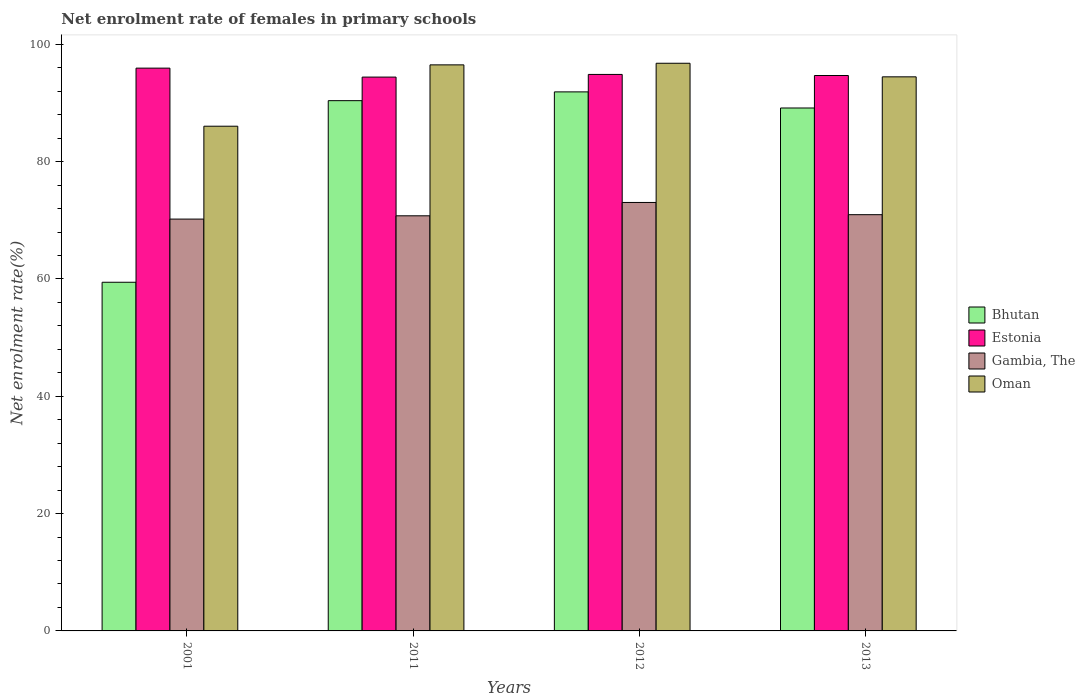How many different coloured bars are there?
Your response must be concise. 4. Are the number of bars per tick equal to the number of legend labels?
Your response must be concise. Yes. Are the number of bars on each tick of the X-axis equal?
Provide a short and direct response. Yes. In how many cases, is the number of bars for a given year not equal to the number of legend labels?
Provide a succinct answer. 0. What is the net enrolment rate of females in primary schools in Bhutan in 2011?
Offer a terse response. 90.39. Across all years, what is the maximum net enrolment rate of females in primary schools in Bhutan?
Your answer should be very brief. 91.89. Across all years, what is the minimum net enrolment rate of females in primary schools in Oman?
Provide a short and direct response. 86.04. What is the total net enrolment rate of females in primary schools in Bhutan in the graph?
Your answer should be very brief. 330.86. What is the difference between the net enrolment rate of females in primary schools in Bhutan in 2011 and that in 2012?
Give a very brief answer. -1.5. What is the difference between the net enrolment rate of females in primary schools in Estonia in 2001 and the net enrolment rate of females in primary schools in Gambia, The in 2012?
Ensure brevity in your answer.  22.9. What is the average net enrolment rate of females in primary schools in Estonia per year?
Ensure brevity in your answer.  94.97. In the year 2012, what is the difference between the net enrolment rate of females in primary schools in Oman and net enrolment rate of females in primary schools in Bhutan?
Offer a very short reply. 4.88. In how many years, is the net enrolment rate of females in primary schools in Oman greater than 52 %?
Keep it short and to the point. 4. What is the ratio of the net enrolment rate of females in primary schools in Oman in 2001 to that in 2013?
Offer a terse response. 0.91. Is the difference between the net enrolment rate of females in primary schools in Oman in 2001 and 2011 greater than the difference between the net enrolment rate of females in primary schools in Bhutan in 2001 and 2011?
Make the answer very short. Yes. What is the difference between the highest and the second highest net enrolment rate of females in primary schools in Bhutan?
Give a very brief answer. 1.5. What is the difference between the highest and the lowest net enrolment rate of females in primary schools in Gambia, The?
Provide a short and direct response. 2.83. In how many years, is the net enrolment rate of females in primary schools in Oman greater than the average net enrolment rate of females in primary schools in Oman taken over all years?
Keep it short and to the point. 3. Is the sum of the net enrolment rate of females in primary schools in Estonia in 2011 and 2012 greater than the maximum net enrolment rate of females in primary schools in Gambia, The across all years?
Provide a succinct answer. Yes. What does the 3rd bar from the left in 2011 represents?
Your answer should be compact. Gambia, The. What does the 1st bar from the right in 2012 represents?
Ensure brevity in your answer.  Oman. Is it the case that in every year, the sum of the net enrolment rate of females in primary schools in Gambia, The and net enrolment rate of females in primary schools in Estonia is greater than the net enrolment rate of females in primary schools in Oman?
Your answer should be very brief. Yes. Are all the bars in the graph horizontal?
Make the answer very short. No. Where does the legend appear in the graph?
Give a very brief answer. Center right. How many legend labels are there?
Make the answer very short. 4. How are the legend labels stacked?
Provide a succinct answer. Vertical. What is the title of the graph?
Make the answer very short. Net enrolment rate of females in primary schools. What is the label or title of the Y-axis?
Provide a short and direct response. Net enrolment rate(%). What is the Net enrolment rate(%) in Bhutan in 2001?
Give a very brief answer. 59.44. What is the Net enrolment rate(%) of Estonia in 2001?
Provide a short and direct response. 95.94. What is the Net enrolment rate(%) of Gambia, The in 2001?
Offer a very short reply. 70.2. What is the Net enrolment rate(%) in Oman in 2001?
Offer a very short reply. 86.04. What is the Net enrolment rate(%) of Bhutan in 2011?
Your answer should be compact. 90.39. What is the Net enrolment rate(%) in Estonia in 2011?
Offer a terse response. 94.41. What is the Net enrolment rate(%) in Gambia, The in 2011?
Ensure brevity in your answer.  70.76. What is the Net enrolment rate(%) in Oman in 2011?
Keep it short and to the point. 96.49. What is the Net enrolment rate(%) of Bhutan in 2012?
Your response must be concise. 91.89. What is the Net enrolment rate(%) in Estonia in 2012?
Give a very brief answer. 94.86. What is the Net enrolment rate(%) of Gambia, The in 2012?
Give a very brief answer. 73.04. What is the Net enrolment rate(%) of Oman in 2012?
Offer a very short reply. 96.77. What is the Net enrolment rate(%) of Bhutan in 2013?
Ensure brevity in your answer.  89.14. What is the Net enrolment rate(%) in Estonia in 2013?
Make the answer very short. 94.68. What is the Net enrolment rate(%) of Gambia, The in 2013?
Offer a terse response. 70.96. What is the Net enrolment rate(%) of Oman in 2013?
Your answer should be very brief. 94.45. Across all years, what is the maximum Net enrolment rate(%) in Bhutan?
Offer a terse response. 91.89. Across all years, what is the maximum Net enrolment rate(%) of Estonia?
Offer a very short reply. 95.94. Across all years, what is the maximum Net enrolment rate(%) of Gambia, The?
Your response must be concise. 73.04. Across all years, what is the maximum Net enrolment rate(%) in Oman?
Give a very brief answer. 96.77. Across all years, what is the minimum Net enrolment rate(%) of Bhutan?
Your answer should be compact. 59.44. Across all years, what is the minimum Net enrolment rate(%) of Estonia?
Offer a terse response. 94.41. Across all years, what is the minimum Net enrolment rate(%) of Gambia, The?
Provide a succinct answer. 70.2. Across all years, what is the minimum Net enrolment rate(%) in Oman?
Offer a terse response. 86.04. What is the total Net enrolment rate(%) in Bhutan in the graph?
Keep it short and to the point. 330.86. What is the total Net enrolment rate(%) of Estonia in the graph?
Keep it short and to the point. 379.89. What is the total Net enrolment rate(%) in Gambia, The in the graph?
Keep it short and to the point. 284.97. What is the total Net enrolment rate(%) in Oman in the graph?
Offer a terse response. 373.75. What is the difference between the Net enrolment rate(%) in Bhutan in 2001 and that in 2011?
Keep it short and to the point. -30.96. What is the difference between the Net enrolment rate(%) of Estonia in 2001 and that in 2011?
Your answer should be very brief. 1.53. What is the difference between the Net enrolment rate(%) of Gambia, The in 2001 and that in 2011?
Ensure brevity in your answer.  -0.56. What is the difference between the Net enrolment rate(%) in Oman in 2001 and that in 2011?
Provide a short and direct response. -10.46. What is the difference between the Net enrolment rate(%) in Bhutan in 2001 and that in 2012?
Provide a succinct answer. -32.45. What is the difference between the Net enrolment rate(%) of Estonia in 2001 and that in 2012?
Make the answer very short. 1.07. What is the difference between the Net enrolment rate(%) in Gambia, The in 2001 and that in 2012?
Give a very brief answer. -2.83. What is the difference between the Net enrolment rate(%) in Oman in 2001 and that in 2012?
Offer a very short reply. -10.73. What is the difference between the Net enrolment rate(%) in Bhutan in 2001 and that in 2013?
Keep it short and to the point. -29.71. What is the difference between the Net enrolment rate(%) in Estonia in 2001 and that in 2013?
Your answer should be very brief. 1.26. What is the difference between the Net enrolment rate(%) in Gambia, The in 2001 and that in 2013?
Provide a succinct answer. -0.75. What is the difference between the Net enrolment rate(%) of Oman in 2001 and that in 2013?
Make the answer very short. -8.42. What is the difference between the Net enrolment rate(%) in Bhutan in 2011 and that in 2012?
Offer a very short reply. -1.5. What is the difference between the Net enrolment rate(%) in Estonia in 2011 and that in 2012?
Your answer should be very brief. -0.45. What is the difference between the Net enrolment rate(%) in Gambia, The in 2011 and that in 2012?
Give a very brief answer. -2.28. What is the difference between the Net enrolment rate(%) of Oman in 2011 and that in 2012?
Make the answer very short. -0.28. What is the difference between the Net enrolment rate(%) of Bhutan in 2011 and that in 2013?
Give a very brief answer. 1.25. What is the difference between the Net enrolment rate(%) in Estonia in 2011 and that in 2013?
Ensure brevity in your answer.  -0.27. What is the difference between the Net enrolment rate(%) in Gambia, The in 2011 and that in 2013?
Your answer should be compact. -0.19. What is the difference between the Net enrolment rate(%) in Oman in 2011 and that in 2013?
Keep it short and to the point. 2.04. What is the difference between the Net enrolment rate(%) in Bhutan in 2012 and that in 2013?
Your response must be concise. 2.75. What is the difference between the Net enrolment rate(%) of Estonia in 2012 and that in 2013?
Offer a very short reply. 0.18. What is the difference between the Net enrolment rate(%) of Gambia, The in 2012 and that in 2013?
Provide a short and direct response. 2.08. What is the difference between the Net enrolment rate(%) of Oman in 2012 and that in 2013?
Your answer should be very brief. 2.31. What is the difference between the Net enrolment rate(%) in Bhutan in 2001 and the Net enrolment rate(%) in Estonia in 2011?
Provide a short and direct response. -34.97. What is the difference between the Net enrolment rate(%) of Bhutan in 2001 and the Net enrolment rate(%) of Gambia, The in 2011?
Provide a succinct answer. -11.33. What is the difference between the Net enrolment rate(%) in Bhutan in 2001 and the Net enrolment rate(%) in Oman in 2011?
Keep it short and to the point. -37.06. What is the difference between the Net enrolment rate(%) in Estonia in 2001 and the Net enrolment rate(%) in Gambia, The in 2011?
Your answer should be very brief. 25.17. What is the difference between the Net enrolment rate(%) of Estonia in 2001 and the Net enrolment rate(%) of Oman in 2011?
Make the answer very short. -0.56. What is the difference between the Net enrolment rate(%) in Gambia, The in 2001 and the Net enrolment rate(%) in Oman in 2011?
Your answer should be very brief. -26.29. What is the difference between the Net enrolment rate(%) of Bhutan in 2001 and the Net enrolment rate(%) of Estonia in 2012?
Offer a terse response. -35.43. What is the difference between the Net enrolment rate(%) in Bhutan in 2001 and the Net enrolment rate(%) in Gambia, The in 2012?
Offer a terse response. -13.6. What is the difference between the Net enrolment rate(%) of Bhutan in 2001 and the Net enrolment rate(%) of Oman in 2012?
Offer a very short reply. -37.33. What is the difference between the Net enrolment rate(%) of Estonia in 2001 and the Net enrolment rate(%) of Gambia, The in 2012?
Give a very brief answer. 22.9. What is the difference between the Net enrolment rate(%) in Estonia in 2001 and the Net enrolment rate(%) in Oman in 2012?
Offer a very short reply. -0.83. What is the difference between the Net enrolment rate(%) of Gambia, The in 2001 and the Net enrolment rate(%) of Oman in 2012?
Provide a short and direct response. -26.56. What is the difference between the Net enrolment rate(%) of Bhutan in 2001 and the Net enrolment rate(%) of Estonia in 2013?
Offer a terse response. -35.24. What is the difference between the Net enrolment rate(%) in Bhutan in 2001 and the Net enrolment rate(%) in Gambia, The in 2013?
Your answer should be compact. -11.52. What is the difference between the Net enrolment rate(%) of Bhutan in 2001 and the Net enrolment rate(%) of Oman in 2013?
Make the answer very short. -35.02. What is the difference between the Net enrolment rate(%) of Estonia in 2001 and the Net enrolment rate(%) of Gambia, The in 2013?
Offer a terse response. 24.98. What is the difference between the Net enrolment rate(%) in Estonia in 2001 and the Net enrolment rate(%) in Oman in 2013?
Provide a short and direct response. 1.48. What is the difference between the Net enrolment rate(%) in Gambia, The in 2001 and the Net enrolment rate(%) in Oman in 2013?
Ensure brevity in your answer.  -24.25. What is the difference between the Net enrolment rate(%) of Bhutan in 2011 and the Net enrolment rate(%) of Estonia in 2012?
Your response must be concise. -4.47. What is the difference between the Net enrolment rate(%) in Bhutan in 2011 and the Net enrolment rate(%) in Gambia, The in 2012?
Give a very brief answer. 17.35. What is the difference between the Net enrolment rate(%) in Bhutan in 2011 and the Net enrolment rate(%) in Oman in 2012?
Your response must be concise. -6.38. What is the difference between the Net enrolment rate(%) of Estonia in 2011 and the Net enrolment rate(%) of Gambia, The in 2012?
Your answer should be compact. 21.37. What is the difference between the Net enrolment rate(%) of Estonia in 2011 and the Net enrolment rate(%) of Oman in 2012?
Your answer should be very brief. -2.36. What is the difference between the Net enrolment rate(%) of Gambia, The in 2011 and the Net enrolment rate(%) of Oman in 2012?
Offer a terse response. -26. What is the difference between the Net enrolment rate(%) of Bhutan in 2011 and the Net enrolment rate(%) of Estonia in 2013?
Offer a very short reply. -4.29. What is the difference between the Net enrolment rate(%) of Bhutan in 2011 and the Net enrolment rate(%) of Gambia, The in 2013?
Keep it short and to the point. 19.43. What is the difference between the Net enrolment rate(%) of Bhutan in 2011 and the Net enrolment rate(%) of Oman in 2013?
Offer a very short reply. -4.06. What is the difference between the Net enrolment rate(%) in Estonia in 2011 and the Net enrolment rate(%) in Gambia, The in 2013?
Offer a terse response. 23.45. What is the difference between the Net enrolment rate(%) of Estonia in 2011 and the Net enrolment rate(%) of Oman in 2013?
Make the answer very short. -0.04. What is the difference between the Net enrolment rate(%) of Gambia, The in 2011 and the Net enrolment rate(%) of Oman in 2013?
Offer a very short reply. -23.69. What is the difference between the Net enrolment rate(%) in Bhutan in 2012 and the Net enrolment rate(%) in Estonia in 2013?
Give a very brief answer. -2.79. What is the difference between the Net enrolment rate(%) in Bhutan in 2012 and the Net enrolment rate(%) in Gambia, The in 2013?
Ensure brevity in your answer.  20.93. What is the difference between the Net enrolment rate(%) of Bhutan in 2012 and the Net enrolment rate(%) of Oman in 2013?
Offer a very short reply. -2.56. What is the difference between the Net enrolment rate(%) of Estonia in 2012 and the Net enrolment rate(%) of Gambia, The in 2013?
Provide a short and direct response. 23.91. What is the difference between the Net enrolment rate(%) in Estonia in 2012 and the Net enrolment rate(%) in Oman in 2013?
Keep it short and to the point. 0.41. What is the difference between the Net enrolment rate(%) in Gambia, The in 2012 and the Net enrolment rate(%) in Oman in 2013?
Offer a very short reply. -21.41. What is the average Net enrolment rate(%) of Bhutan per year?
Provide a succinct answer. 82.72. What is the average Net enrolment rate(%) in Estonia per year?
Provide a succinct answer. 94.97. What is the average Net enrolment rate(%) in Gambia, The per year?
Make the answer very short. 71.24. What is the average Net enrolment rate(%) of Oman per year?
Provide a short and direct response. 93.44. In the year 2001, what is the difference between the Net enrolment rate(%) of Bhutan and Net enrolment rate(%) of Estonia?
Give a very brief answer. -36.5. In the year 2001, what is the difference between the Net enrolment rate(%) of Bhutan and Net enrolment rate(%) of Gambia, The?
Make the answer very short. -10.77. In the year 2001, what is the difference between the Net enrolment rate(%) of Bhutan and Net enrolment rate(%) of Oman?
Your answer should be very brief. -26.6. In the year 2001, what is the difference between the Net enrolment rate(%) in Estonia and Net enrolment rate(%) in Gambia, The?
Provide a short and direct response. 25.73. In the year 2001, what is the difference between the Net enrolment rate(%) of Estonia and Net enrolment rate(%) of Oman?
Make the answer very short. 9.9. In the year 2001, what is the difference between the Net enrolment rate(%) in Gambia, The and Net enrolment rate(%) in Oman?
Provide a short and direct response. -15.83. In the year 2011, what is the difference between the Net enrolment rate(%) of Bhutan and Net enrolment rate(%) of Estonia?
Provide a short and direct response. -4.02. In the year 2011, what is the difference between the Net enrolment rate(%) of Bhutan and Net enrolment rate(%) of Gambia, The?
Offer a very short reply. 19.63. In the year 2011, what is the difference between the Net enrolment rate(%) of Bhutan and Net enrolment rate(%) of Oman?
Give a very brief answer. -6.1. In the year 2011, what is the difference between the Net enrolment rate(%) of Estonia and Net enrolment rate(%) of Gambia, The?
Provide a short and direct response. 23.65. In the year 2011, what is the difference between the Net enrolment rate(%) in Estonia and Net enrolment rate(%) in Oman?
Make the answer very short. -2.08. In the year 2011, what is the difference between the Net enrolment rate(%) in Gambia, The and Net enrolment rate(%) in Oman?
Offer a very short reply. -25.73. In the year 2012, what is the difference between the Net enrolment rate(%) in Bhutan and Net enrolment rate(%) in Estonia?
Keep it short and to the point. -2.97. In the year 2012, what is the difference between the Net enrolment rate(%) of Bhutan and Net enrolment rate(%) of Gambia, The?
Offer a terse response. 18.85. In the year 2012, what is the difference between the Net enrolment rate(%) of Bhutan and Net enrolment rate(%) of Oman?
Offer a very short reply. -4.88. In the year 2012, what is the difference between the Net enrolment rate(%) in Estonia and Net enrolment rate(%) in Gambia, The?
Give a very brief answer. 21.82. In the year 2012, what is the difference between the Net enrolment rate(%) of Estonia and Net enrolment rate(%) of Oman?
Provide a short and direct response. -1.91. In the year 2012, what is the difference between the Net enrolment rate(%) of Gambia, The and Net enrolment rate(%) of Oman?
Provide a succinct answer. -23.73. In the year 2013, what is the difference between the Net enrolment rate(%) of Bhutan and Net enrolment rate(%) of Estonia?
Ensure brevity in your answer.  -5.54. In the year 2013, what is the difference between the Net enrolment rate(%) in Bhutan and Net enrolment rate(%) in Gambia, The?
Your answer should be very brief. 18.19. In the year 2013, what is the difference between the Net enrolment rate(%) of Bhutan and Net enrolment rate(%) of Oman?
Ensure brevity in your answer.  -5.31. In the year 2013, what is the difference between the Net enrolment rate(%) in Estonia and Net enrolment rate(%) in Gambia, The?
Offer a very short reply. 23.72. In the year 2013, what is the difference between the Net enrolment rate(%) in Estonia and Net enrolment rate(%) in Oman?
Your response must be concise. 0.23. In the year 2013, what is the difference between the Net enrolment rate(%) of Gambia, The and Net enrolment rate(%) of Oman?
Keep it short and to the point. -23.5. What is the ratio of the Net enrolment rate(%) in Bhutan in 2001 to that in 2011?
Provide a short and direct response. 0.66. What is the ratio of the Net enrolment rate(%) in Estonia in 2001 to that in 2011?
Ensure brevity in your answer.  1.02. What is the ratio of the Net enrolment rate(%) of Oman in 2001 to that in 2011?
Offer a very short reply. 0.89. What is the ratio of the Net enrolment rate(%) in Bhutan in 2001 to that in 2012?
Make the answer very short. 0.65. What is the ratio of the Net enrolment rate(%) in Estonia in 2001 to that in 2012?
Provide a short and direct response. 1.01. What is the ratio of the Net enrolment rate(%) in Gambia, The in 2001 to that in 2012?
Your answer should be compact. 0.96. What is the ratio of the Net enrolment rate(%) of Oman in 2001 to that in 2012?
Your answer should be very brief. 0.89. What is the ratio of the Net enrolment rate(%) in Bhutan in 2001 to that in 2013?
Offer a terse response. 0.67. What is the ratio of the Net enrolment rate(%) of Estonia in 2001 to that in 2013?
Make the answer very short. 1.01. What is the ratio of the Net enrolment rate(%) of Gambia, The in 2001 to that in 2013?
Provide a succinct answer. 0.99. What is the ratio of the Net enrolment rate(%) of Oman in 2001 to that in 2013?
Offer a very short reply. 0.91. What is the ratio of the Net enrolment rate(%) of Bhutan in 2011 to that in 2012?
Your answer should be compact. 0.98. What is the ratio of the Net enrolment rate(%) of Estonia in 2011 to that in 2012?
Give a very brief answer. 1. What is the ratio of the Net enrolment rate(%) in Gambia, The in 2011 to that in 2012?
Give a very brief answer. 0.97. What is the ratio of the Net enrolment rate(%) of Estonia in 2011 to that in 2013?
Your answer should be compact. 1. What is the ratio of the Net enrolment rate(%) of Oman in 2011 to that in 2013?
Keep it short and to the point. 1.02. What is the ratio of the Net enrolment rate(%) of Bhutan in 2012 to that in 2013?
Your response must be concise. 1.03. What is the ratio of the Net enrolment rate(%) in Gambia, The in 2012 to that in 2013?
Ensure brevity in your answer.  1.03. What is the ratio of the Net enrolment rate(%) of Oman in 2012 to that in 2013?
Offer a very short reply. 1.02. What is the difference between the highest and the second highest Net enrolment rate(%) of Bhutan?
Make the answer very short. 1.5. What is the difference between the highest and the second highest Net enrolment rate(%) in Estonia?
Offer a terse response. 1.07. What is the difference between the highest and the second highest Net enrolment rate(%) in Gambia, The?
Offer a terse response. 2.08. What is the difference between the highest and the second highest Net enrolment rate(%) of Oman?
Keep it short and to the point. 0.28. What is the difference between the highest and the lowest Net enrolment rate(%) of Bhutan?
Offer a terse response. 32.45. What is the difference between the highest and the lowest Net enrolment rate(%) in Estonia?
Your answer should be compact. 1.53. What is the difference between the highest and the lowest Net enrolment rate(%) of Gambia, The?
Your answer should be compact. 2.83. What is the difference between the highest and the lowest Net enrolment rate(%) of Oman?
Provide a succinct answer. 10.73. 